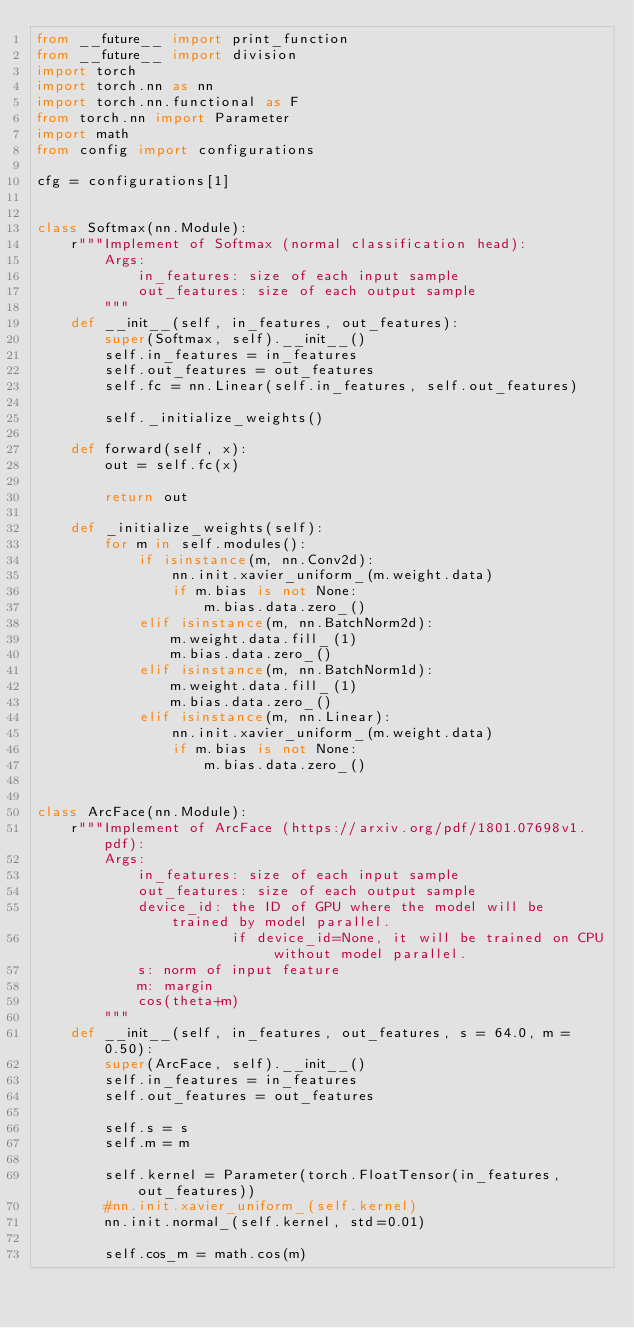Convert code to text. <code><loc_0><loc_0><loc_500><loc_500><_Python_>from __future__ import print_function
from __future__ import division
import torch
import torch.nn as nn
import torch.nn.functional as F
from torch.nn import Parameter
import math
from config import configurations

cfg = configurations[1]


class Softmax(nn.Module):
    r"""Implement of Softmax (normal classification head):
        Args:
            in_features: size of each input sample
            out_features: size of each output sample
        """
    def __init__(self, in_features, out_features):
        super(Softmax, self).__init__()
        self.in_features = in_features
        self.out_features = out_features
        self.fc = nn.Linear(self.in_features, self.out_features)

        self._initialize_weights()

    def forward(self, x):
        out = self.fc(x)

        return out

    def _initialize_weights(self):
        for m in self.modules():
            if isinstance(m, nn.Conv2d):
                nn.init.xavier_uniform_(m.weight.data)
                if m.bias is not None:
                    m.bias.data.zero_()
            elif isinstance(m, nn.BatchNorm2d):
                m.weight.data.fill_(1)
                m.bias.data.zero_()
            elif isinstance(m, nn.BatchNorm1d):
                m.weight.data.fill_(1)
                m.bias.data.zero_()
            elif isinstance(m, nn.Linear):
                nn.init.xavier_uniform_(m.weight.data)
                if m.bias is not None:
                    m.bias.data.zero_()


class ArcFace(nn.Module):
    r"""Implement of ArcFace (https://arxiv.org/pdf/1801.07698v1.pdf):
        Args:
            in_features: size of each input sample
            out_features: size of each output sample
            device_id: the ID of GPU where the model will be trained by model parallel. 
                       if device_id=None, it will be trained on CPU without model parallel.
            s: norm of input feature
            m: margin
            cos(theta+m)
        """
    def __init__(self, in_features, out_features, s = 64.0, m = 0.50):
        super(ArcFace, self).__init__()
        self.in_features = in_features
        self.out_features = out_features

        self.s = s
        self.m = m
        
        self.kernel = Parameter(torch.FloatTensor(in_features, out_features))
        #nn.init.xavier_uniform_(self.kernel)
        nn.init.normal_(self.kernel, std=0.01)

        self.cos_m = math.cos(m)</code> 